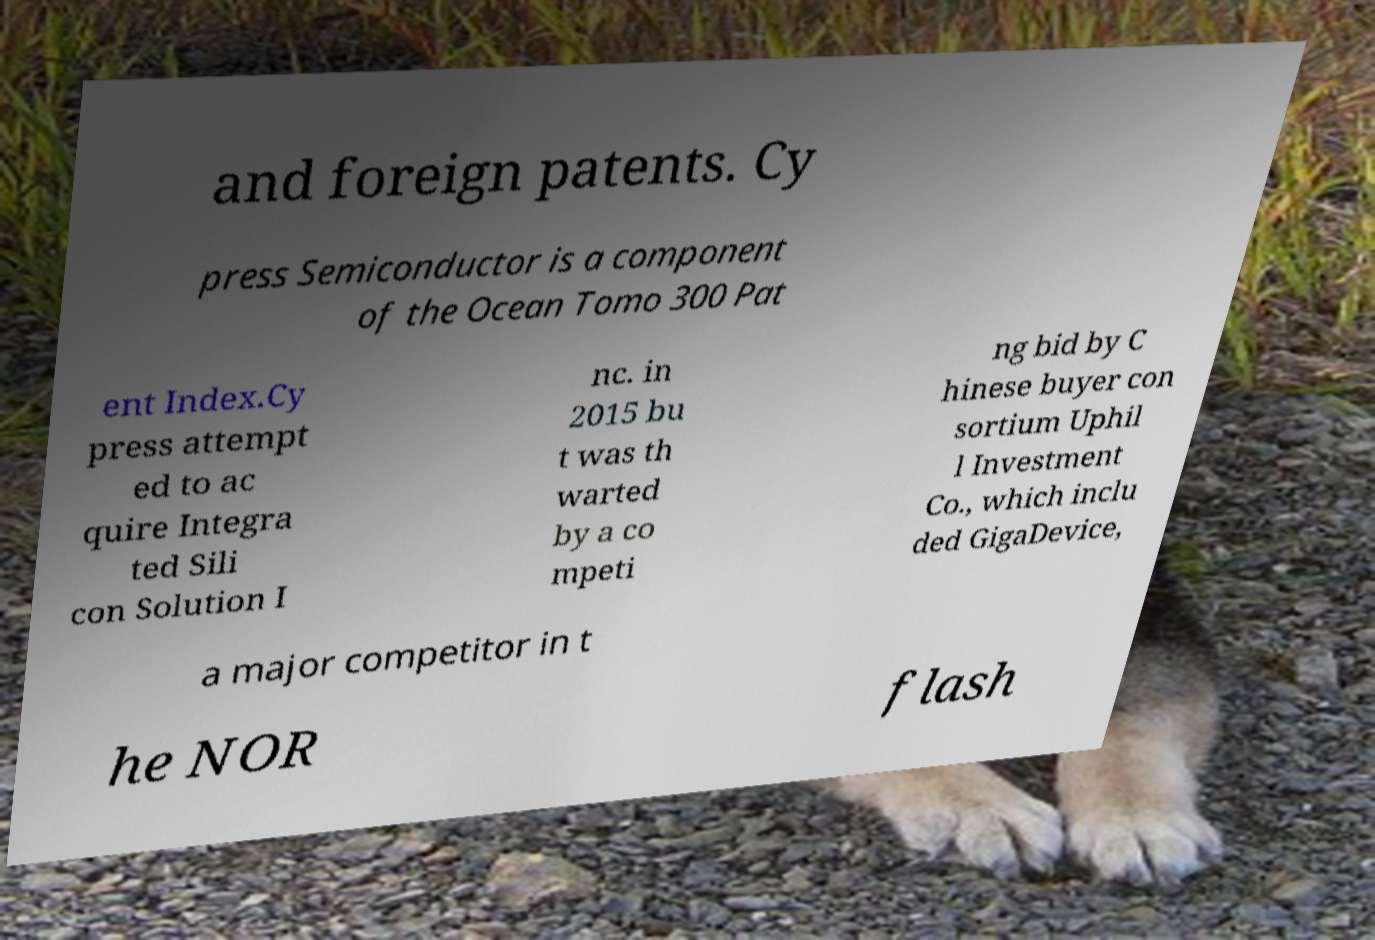For documentation purposes, I need the text within this image transcribed. Could you provide that? and foreign patents. Cy press Semiconductor is a component of the Ocean Tomo 300 Pat ent Index.Cy press attempt ed to ac quire Integra ted Sili con Solution I nc. in 2015 bu t was th warted by a co mpeti ng bid by C hinese buyer con sortium Uphil l Investment Co., which inclu ded GigaDevice, a major competitor in t he NOR flash 